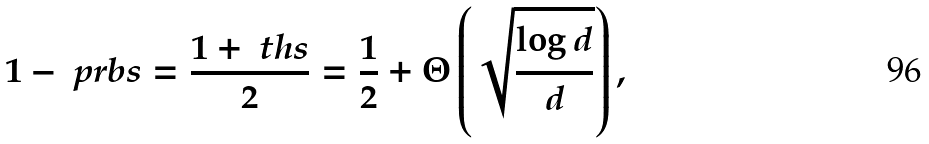Convert formula to latex. <formula><loc_0><loc_0><loc_500><loc_500>1 - \ p r b s = \frac { 1 + \ t h s } { 2 } = \frac { 1 } { 2 } + \Theta \left ( \sqrt { \frac { \log d } { d } } \right ) ,</formula> 